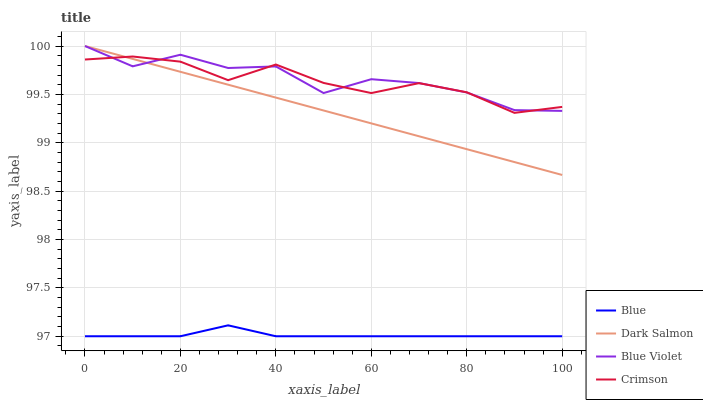Does Blue have the minimum area under the curve?
Answer yes or no. Yes. Does Blue Violet have the maximum area under the curve?
Answer yes or no. Yes. Does Crimson have the minimum area under the curve?
Answer yes or no. No. Does Crimson have the maximum area under the curve?
Answer yes or no. No. Is Dark Salmon the smoothest?
Answer yes or no. Yes. Is Blue Violet the roughest?
Answer yes or no. Yes. Is Crimson the smoothest?
Answer yes or no. No. Is Crimson the roughest?
Answer yes or no. No. Does Crimson have the lowest value?
Answer yes or no. No. Does Crimson have the highest value?
Answer yes or no. No. Is Blue less than Crimson?
Answer yes or no. Yes. Is Crimson greater than Blue?
Answer yes or no. Yes. Does Blue intersect Crimson?
Answer yes or no. No. 